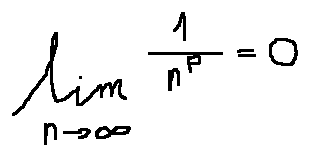Convert formula to latex. <formula><loc_0><loc_0><loc_500><loc_500>\lim \lim i t s _ { n \rightarrow \infty } \frac { 1 } { n ^ { p } } = 0</formula> 